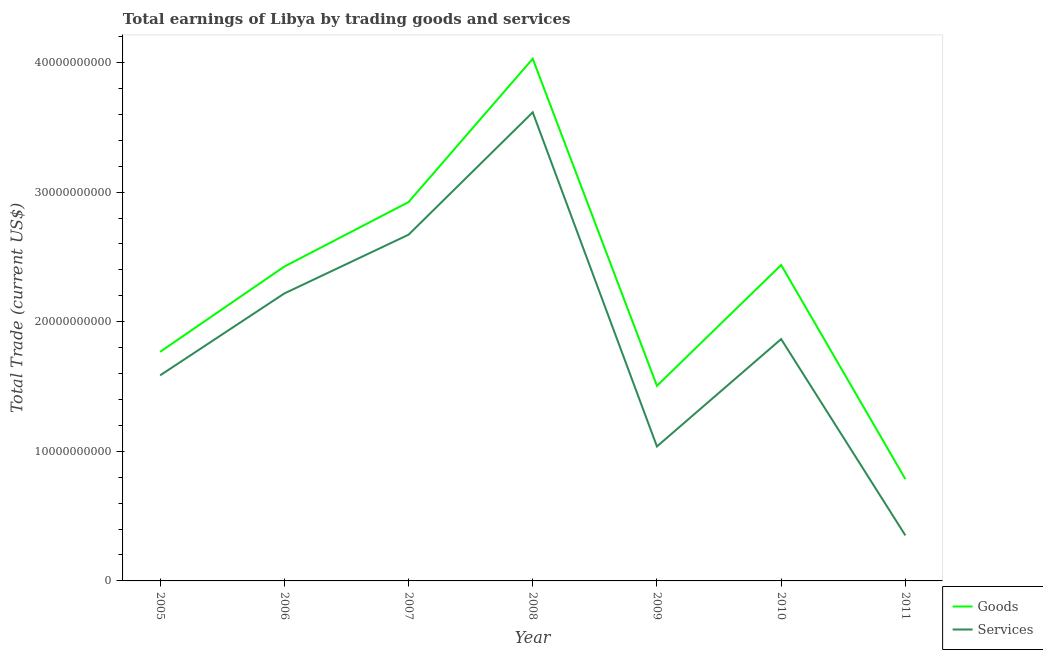How many different coloured lines are there?
Give a very brief answer. 2. Is the number of lines equal to the number of legend labels?
Your response must be concise. Yes. What is the amount earned by trading goods in 2011?
Your response must be concise. 7.86e+09. Across all years, what is the maximum amount earned by trading services?
Offer a very short reply. 3.62e+1. Across all years, what is the minimum amount earned by trading services?
Offer a terse response. 3.51e+09. In which year was the amount earned by trading goods maximum?
Give a very brief answer. 2008. What is the total amount earned by trading services in the graph?
Offer a terse response. 1.33e+11. What is the difference between the amount earned by trading goods in 2006 and that in 2010?
Offer a very short reply. -1.22e+08. What is the difference between the amount earned by trading services in 2007 and the amount earned by trading goods in 2011?
Your response must be concise. 1.89e+1. What is the average amount earned by trading services per year?
Your answer should be very brief. 1.91e+1. In the year 2006, what is the difference between the amount earned by trading services and amount earned by trading goods?
Give a very brief answer. -2.08e+09. What is the ratio of the amount earned by trading services in 2005 to that in 2007?
Offer a terse response. 0.59. What is the difference between the highest and the second highest amount earned by trading goods?
Make the answer very short. 1.11e+1. What is the difference between the highest and the lowest amount earned by trading services?
Keep it short and to the point. 3.26e+1. In how many years, is the amount earned by trading goods greater than the average amount earned by trading goods taken over all years?
Your answer should be compact. 4. Is the sum of the amount earned by trading goods in 2005 and 2010 greater than the maximum amount earned by trading services across all years?
Offer a terse response. Yes. Is the amount earned by trading services strictly greater than the amount earned by trading goods over the years?
Provide a succinct answer. No. Does the graph contain any zero values?
Your response must be concise. No. Where does the legend appear in the graph?
Offer a terse response. Bottom right. How are the legend labels stacked?
Offer a terse response. Vertical. What is the title of the graph?
Offer a very short reply. Total earnings of Libya by trading goods and services. What is the label or title of the X-axis?
Provide a short and direct response. Year. What is the label or title of the Y-axis?
Provide a short and direct response. Total Trade (current US$). What is the Total Trade (current US$) of Goods in 2005?
Ensure brevity in your answer.  1.77e+1. What is the Total Trade (current US$) of Services in 2005?
Provide a short and direct response. 1.59e+1. What is the Total Trade (current US$) of Goods in 2006?
Your answer should be compact. 2.43e+1. What is the Total Trade (current US$) in Services in 2006?
Your response must be concise. 2.22e+1. What is the Total Trade (current US$) of Goods in 2007?
Make the answer very short. 2.92e+1. What is the Total Trade (current US$) in Services in 2007?
Make the answer very short. 2.67e+1. What is the Total Trade (current US$) of Goods in 2008?
Your response must be concise. 4.03e+1. What is the Total Trade (current US$) of Services in 2008?
Your answer should be very brief. 3.62e+1. What is the Total Trade (current US$) in Goods in 2009?
Ensure brevity in your answer.  1.51e+1. What is the Total Trade (current US$) of Services in 2009?
Give a very brief answer. 1.04e+1. What is the Total Trade (current US$) of Goods in 2010?
Offer a terse response. 2.44e+1. What is the Total Trade (current US$) in Services in 2010?
Make the answer very short. 1.87e+1. What is the Total Trade (current US$) of Goods in 2011?
Your answer should be compact. 7.86e+09. What is the Total Trade (current US$) in Services in 2011?
Your answer should be compact. 3.51e+09. Across all years, what is the maximum Total Trade (current US$) of Goods?
Your response must be concise. 4.03e+1. Across all years, what is the maximum Total Trade (current US$) of Services?
Ensure brevity in your answer.  3.62e+1. Across all years, what is the minimum Total Trade (current US$) in Goods?
Ensure brevity in your answer.  7.86e+09. Across all years, what is the minimum Total Trade (current US$) of Services?
Make the answer very short. 3.51e+09. What is the total Total Trade (current US$) in Goods in the graph?
Offer a terse response. 1.59e+11. What is the total Total Trade (current US$) in Services in the graph?
Make the answer very short. 1.33e+11. What is the difference between the Total Trade (current US$) of Goods in 2005 and that in 2006?
Your answer should be very brief. -6.58e+09. What is the difference between the Total Trade (current US$) in Services in 2005 and that in 2006?
Provide a short and direct response. -6.32e+09. What is the difference between the Total Trade (current US$) in Goods in 2005 and that in 2007?
Provide a short and direct response. -1.16e+1. What is the difference between the Total Trade (current US$) in Services in 2005 and that in 2007?
Offer a very short reply. -1.09e+1. What is the difference between the Total Trade (current US$) of Goods in 2005 and that in 2008?
Make the answer very short. -2.26e+1. What is the difference between the Total Trade (current US$) of Services in 2005 and that in 2008?
Ensure brevity in your answer.  -2.03e+1. What is the difference between the Total Trade (current US$) in Goods in 2005 and that in 2009?
Your answer should be compact. 2.62e+09. What is the difference between the Total Trade (current US$) in Services in 2005 and that in 2009?
Your answer should be compact. 5.48e+09. What is the difference between the Total Trade (current US$) in Goods in 2005 and that in 2010?
Offer a very short reply. -6.70e+09. What is the difference between the Total Trade (current US$) in Services in 2005 and that in 2010?
Ensure brevity in your answer.  -2.80e+09. What is the difference between the Total Trade (current US$) of Goods in 2005 and that in 2011?
Provide a short and direct response. 9.82e+09. What is the difference between the Total Trade (current US$) of Services in 2005 and that in 2011?
Offer a terse response. 1.23e+1. What is the difference between the Total Trade (current US$) of Goods in 2006 and that in 2007?
Give a very brief answer. -4.97e+09. What is the difference between the Total Trade (current US$) in Services in 2006 and that in 2007?
Provide a succinct answer. -4.53e+09. What is the difference between the Total Trade (current US$) of Goods in 2006 and that in 2008?
Your response must be concise. -1.60e+1. What is the difference between the Total Trade (current US$) in Services in 2006 and that in 2008?
Your answer should be compact. -1.40e+1. What is the difference between the Total Trade (current US$) of Goods in 2006 and that in 2009?
Give a very brief answer. 9.20e+09. What is the difference between the Total Trade (current US$) of Services in 2006 and that in 2009?
Offer a very short reply. 1.18e+1. What is the difference between the Total Trade (current US$) in Goods in 2006 and that in 2010?
Keep it short and to the point. -1.22e+08. What is the difference between the Total Trade (current US$) of Services in 2006 and that in 2010?
Make the answer very short. 3.52e+09. What is the difference between the Total Trade (current US$) of Goods in 2006 and that in 2011?
Provide a succinct answer. 1.64e+1. What is the difference between the Total Trade (current US$) of Services in 2006 and that in 2011?
Provide a short and direct response. 1.87e+1. What is the difference between the Total Trade (current US$) of Goods in 2007 and that in 2008?
Offer a terse response. -1.11e+1. What is the difference between the Total Trade (current US$) of Services in 2007 and that in 2008?
Your response must be concise. -9.44e+09. What is the difference between the Total Trade (current US$) in Goods in 2007 and that in 2009?
Ensure brevity in your answer.  1.42e+1. What is the difference between the Total Trade (current US$) of Services in 2007 and that in 2009?
Your answer should be compact. 1.63e+1. What is the difference between the Total Trade (current US$) in Goods in 2007 and that in 2010?
Ensure brevity in your answer.  4.85e+09. What is the difference between the Total Trade (current US$) of Services in 2007 and that in 2010?
Offer a terse response. 8.05e+09. What is the difference between the Total Trade (current US$) of Goods in 2007 and that in 2011?
Provide a succinct answer. 2.14e+1. What is the difference between the Total Trade (current US$) in Services in 2007 and that in 2011?
Make the answer very short. 2.32e+1. What is the difference between the Total Trade (current US$) in Goods in 2008 and that in 2009?
Keep it short and to the point. 2.52e+1. What is the difference between the Total Trade (current US$) in Services in 2008 and that in 2009?
Give a very brief answer. 2.58e+1. What is the difference between the Total Trade (current US$) in Goods in 2008 and that in 2010?
Provide a succinct answer. 1.59e+1. What is the difference between the Total Trade (current US$) in Services in 2008 and that in 2010?
Provide a short and direct response. 1.75e+1. What is the difference between the Total Trade (current US$) of Goods in 2008 and that in 2011?
Provide a succinct answer. 3.24e+1. What is the difference between the Total Trade (current US$) of Services in 2008 and that in 2011?
Offer a very short reply. 3.26e+1. What is the difference between the Total Trade (current US$) of Goods in 2009 and that in 2010?
Ensure brevity in your answer.  -9.32e+09. What is the difference between the Total Trade (current US$) of Services in 2009 and that in 2010?
Offer a terse response. -8.28e+09. What is the difference between the Total Trade (current US$) of Goods in 2009 and that in 2011?
Offer a very short reply. 7.19e+09. What is the difference between the Total Trade (current US$) in Services in 2009 and that in 2011?
Your answer should be compact. 6.86e+09. What is the difference between the Total Trade (current US$) of Goods in 2010 and that in 2011?
Provide a succinct answer. 1.65e+1. What is the difference between the Total Trade (current US$) of Services in 2010 and that in 2011?
Ensure brevity in your answer.  1.51e+1. What is the difference between the Total Trade (current US$) of Goods in 2005 and the Total Trade (current US$) of Services in 2006?
Ensure brevity in your answer.  -4.50e+09. What is the difference between the Total Trade (current US$) of Goods in 2005 and the Total Trade (current US$) of Services in 2007?
Make the answer very short. -9.04e+09. What is the difference between the Total Trade (current US$) of Goods in 2005 and the Total Trade (current US$) of Services in 2008?
Ensure brevity in your answer.  -1.85e+1. What is the difference between the Total Trade (current US$) in Goods in 2005 and the Total Trade (current US$) in Services in 2009?
Ensure brevity in your answer.  7.30e+09. What is the difference between the Total Trade (current US$) in Goods in 2005 and the Total Trade (current US$) in Services in 2010?
Ensure brevity in your answer.  -9.84e+08. What is the difference between the Total Trade (current US$) in Goods in 2005 and the Total Trade (current US$) in Services in 2011?
Give a very brief answer. 1.42e+1. What is the difference between the Total Trade (current US$) in Goods in 2006 and the Total Trade (current US$) in Services in 2007?
Keep it short and to the point. -2.46e+09. What is the difference between the Total Trade (current US$) of Goods in 2006 and the Total Trade (current US$) of Services in 2008?
Give a very brief answer. -1.19e+1. What is the difference between the Total Trade (current US$) in Goods in 2006 and the Total Trade (current US$) in Services in 2009?
Your response must be concise. 1.39e+1. What is the difference between the Total Trade (current US$) of Goods in 2006 and the Total Trade (current US$) of Services in 2010?
Your answer should be compact. 5.60e+09. What is the difference between the Total Trade (current US$) of Goods in 2006 and the Total Trade (current US$) of Services in 2011?
Ensure brevity in your answer.  2.07e+1. What is the difference between the Total Trade (current US$) of Goods in 2007 and the Total Trade (current US$) of Services in 2008?
Your answer should be very brief. -6.93e+09. What is the difference between the Total Trade (current US$) of Goods in 2007 and the Total Trade (current US$) of Services in 2009?
Ensure brevity in your answer.  1.89e+1. What is the difference between the Total Trade (current US$) in Goods in 2007 and the Total Trade (current US$) in Services in 2010?
Your response must be concise. 1.06e+1. What is the difference between the Total Trade (current US$) in Goods in 2007 and the Total Trade (current US$) in Services in 2011?
Make the answer very short. 2.57e+1. What is the difference between the Total Trade (current US$) of Goods in 2008 and the Total Trade (current US$) of Services in 2009?
Offer a terse response. 2.99e+1. What is the difference between the Total Trade (current US$) in Goods in 2008 and the Total Trade (current US$) in Services in 2010?
Keep it short and to the point. 2.16e+1. What is the difference between the Total Trade (current US$) in Goods in 2008 and the Total Trade (current US$) in Services in 2011?
Provide a short and direct response. 3.68e+1. What is the difference between the Total Trade (current US$) in Goods in 2009 and the Total Trade (current US$) in Services in 2010?
Keep it short and to the point. -3.61e+09. What is the difference between the Total Trade (current US$) in Goods in 2009 and the Total Trade (current US$) in Services in 2011?
Your answer should be compact. 1.15e+1. What is the difference between the Total Trade (current US$) in Goods in 2010 and the Total Trade (current US$) in Services in 2011?
Offer a terse response. 2.09e+1. What is the average Total Trade (current US$) of Goods per year?
Give a very brief answer. 2.27e+1. What is the average Total Trade (current US$) in Services per year?
Provide a short and direct response. 1.91e+1. In the year 2005, what is the difference between the Total Trade (current US$) of Goods and Total Trade (current US$) of Services?
Give a very brief answer. 1.82e+09. In the year 2006, what is the difference between the Total Trade (current US$) in Goods and Total Trade (current US$) in Services?
Offer a terse response. 2.08e+09. In the year 2007, what is the difference between the Total Trade (current US$) in Goods and Total Trade (current US$) in Services?
Offer a very short reply. 2.52e+09. In the year 2008, what is the difference between the Total Trade (current US$) in Goods and Total Trade (current US$) in Services?
Provide a short and direct response. 4.14e+09. In the year 2009, what is the difference between the Total Trade (current US$) of Goods and Total Trade (current US$) of Services?
Offer a terse response. 4.68e+09. In the year 2010, what is the difference between the Total Trade (current US$) of Goods and Total Trade (current US$) of Services?
Give a very brief answer. 5.72e+09. In the year 2011, what is the difference between the Total Trade (current US$) in Goods and Total Trade (current US$) in Services?
Offer a terse response. 4.35e+09. What is the ratio of the Total Trade (current US$) of Goods in 2005 to that in 2006?
Your answer should be compact. 0.73. What is the ratio of the Total Trade (current US$) of Services in 2005 to that in 2006?
Ensure brevity in your answer.  0.72. What is the ratio of the Total Trade (current US$) of Goods in 2005 to that in 2007?
Make the answer very short. 0.6. What is the ratio of the Total Trade (current US$) in Services in 2005 to that in 2007?
Provide a short and direct response. 0.59. What is the ratio of the Total Trade (current US$) of Goods in 2005 to that in 2008?
Your answer should be compact. 0.44. What is the ratio of the Total Trade (current US$) in Services in 2005 to that in 2008?
Give a very brief answer. 0.44. What is the ratio of the Total Trade (current US$) of Goods in 2005 to that in 2009?
Offer a terse response. 1.17. What is the ratio of the Total Trade (current US$) of Services in 2005 to that in 2009?
Offer a terse response. 1.53. What is the ratio of the Total Trade (current US$) in Goods in 2005 to that in 2010?
Ensure brevity in your answer.  0.73. What is the ratio of the Total Trade (current US$) in Services in 2005 to that in 2010?
Give a very brief answer. 0.85. What is the ratio of the Total Trade (current US$) of Goods in 2005 to that in 2011?
Give a very brief answer. 2.25. What is the ratio of the Total Trade (current US$) of Services in 2005 to that in 2011?
Provide a succinct answer. 4.51. What is the ratio of the Total Trade (current US$) of Goods in 2006 to that in 2007?
Give a very brief answer. 0.83. What is the ratio of the Total Trade (current US$) in Services in 2006 to that in 2007?
Provide a short and direct response. 0.83. What is the ratio of the Total Trade (current US$) of Goods in 2006 to that in 2008?
Offer a terse response. 0.6. What is the ratio of the Total Trade (current US$) of Services in 2006 to that in 2008?
Provide a short and direct response. 0.61. What is the ratio of the Total Trade (current US$) of Goods in 2006 to that in 2009?
Your answer should be compact. 1.61. What is the ratio of the Total Trade (current US$) of Services in 2006 to that in 2009?
Offer a very short reply. 2.14. What is the ratio of the Total Trade (current US$) of Services in 2006 to that in 2010?
Your response must be concise. 1.19. What is the ratio of the Total Trade (current US$) in Goods in 2006 to that in 2011?
Offer a terse response. 3.09. What is the ratio of the Total Trade (current US$) of Services in 2006 to that in 2011?
Provide a short and direct response. 6.31. What is the ratio of the Total Trade (current US$) in Goods in 2007 to that in 2008?
Give a very brief answer. 0.73. What is the ratio of the Total Trade (current US$) in Services in 2007 to that in 2008?
Your response must be concise. 0.74. What is the ratio of the Total Trade (current US$) of Goods in 2007 to that in 2009?
Keep it short and to the point. 1.94. What is the ratio of the Total Trade (current US$) in Services in 2007 to that in 2009?
Provide a short and direct response. 2.57. What is the ratio of the Total Trade (current US$) of Goods in 2007 to that in 2010?
Give a very brief answer. 1.2. What is the ratio of the Total Trade (current US$) of Services in 2007 to that in 2010?
Keep it short and to the point. 1.43. What is the ratio of the Total Trade (current US$) of Goods in 2007 to that in 2011?
Offer a terse response. 3.72. What is the ratio of the Total Trade (current US$) in Services in 2007 to that in 2011?
Your answer should be compact. 7.6. What is the ratio of the Total Trade (current US$) of Goods in 2008 to that in 2009?
Provide a succinct answer. 2.68. What is the ratio of the Total Trade (current US$) in Services in 2008 to that in 2009?
Give a very brief answer. 3.48. What is the ratio of the Total Trade (current US$) in Goods in 2008 to that in 2010?
Provide a short and direct response. 1.65. What is the ratio of the Total Trade (current US$) in Services in 2008 to that in 2010?
Provide a succinct answer. 1.94. What is the ratio of the Total Trade (current US$) in Goods in 2008 to that in 2011?
Offer a terse response. 5.13. What is the ratio of the Total Trade (current US$) of Services in 2008 to that in 2011?
Provide a succinct answer. 10.29. What is the ratio of the Total Trade (current US$) of Goods in 2009 to that in 2010?
Provide a short and direct response. 0.62. What is the ratio of the Total Trade (current US$) of Services in 2009 to that in 2010?
Your response must be concise. 0.56. What is the ratio of the Total Trade (current US$) of Goods in 2009 to that in 2011?
Provide a short and direct response. 1.92. What is the ratio of the Total Trade (current US$) of Services in 2009 to that in 2011?
Make the answer very short. 2.95. What is the ratio of the Total Trade (current US$) in Goods in 2010 to that in 2011?
Your answer should be compact. 3.1. What is the ratio of the Total Trade (current US$) in Services in 2010 to that in 2011?
Provide a short and direct response. 5.31. What is the difference between the highest and the second highest Total Trade (current US$) of Goods?
Offer a very short reply. 1.11e+1. What is the difference between the highest and the second highest Total Trade (current US$) of Services?
Provide a succinct answer. 9.44e+09. What is the difference between the highest and the lowest Total Trade (current US$) in Goods?
Offer a terse response. 3.24e+1. What is the difference between the highest and the lowest Total Trade (current US$) of Services?
Your answer should be compact. 3.26e+1. 